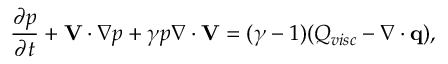Convert formula to latex. <formula><loc_0><loc_0><loc_500><loc_500>\frac { \partial p } { \partial t } + V \cdot \nabla p + \gamma p \nabla \cdot V = ( \gamma - 1 ) ( Q _ { v i s c } - \nabla \cdot q ) ,</formula> 